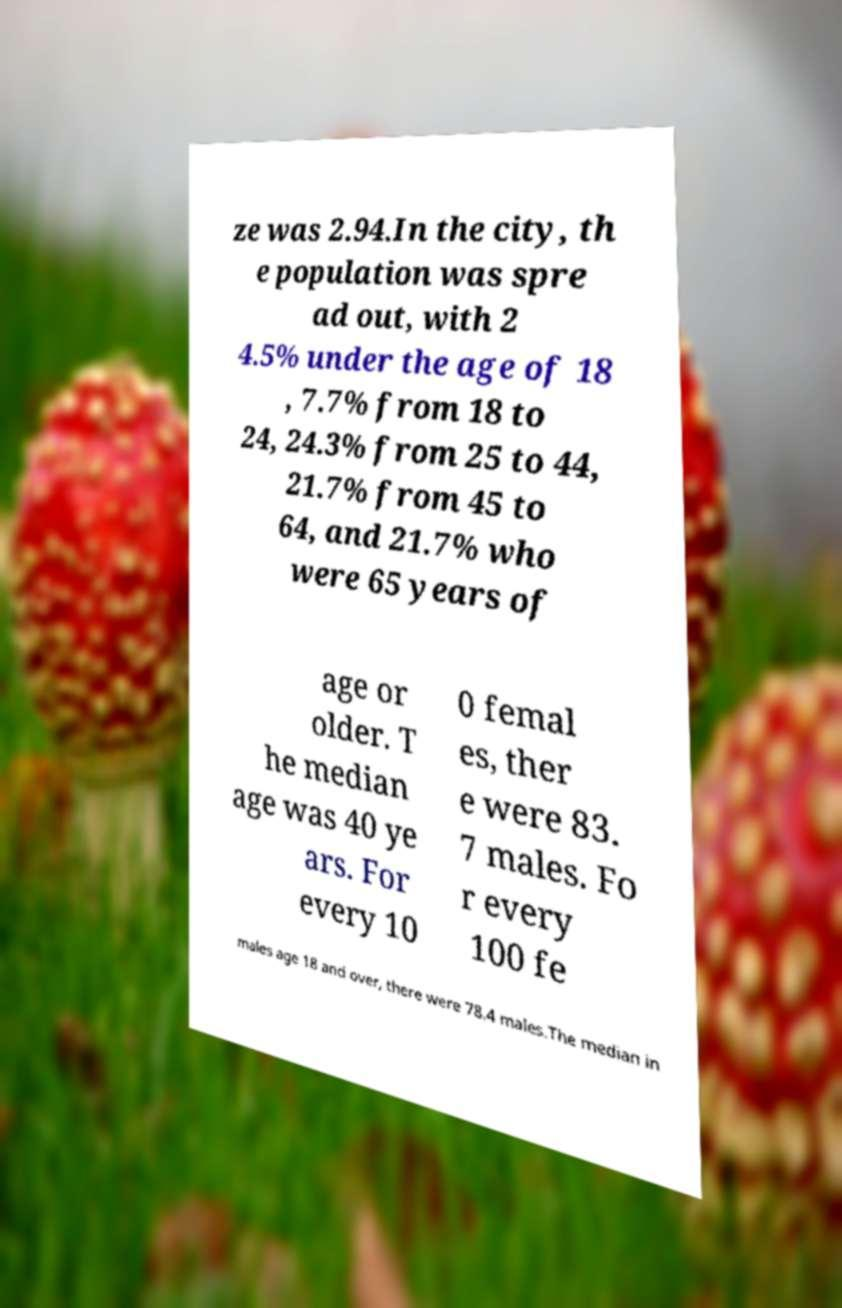Please read and relay the text visible in this image. What does it say? ze was 2.94.In the city, th e population was spre ad out, with 2 4.5% under the age of 18 , 7.7% from 18 to 24, 24.3% from 25 to 44, 21.7% from 45 to 64, and 21.7% who were 65 years of age or older. T he median age was 40 ye ars. For every 10 0 femal es, ther e were 83. 7 males. Fo r every 100 fe males age 18 and over, there were 78.4 males.The median in 